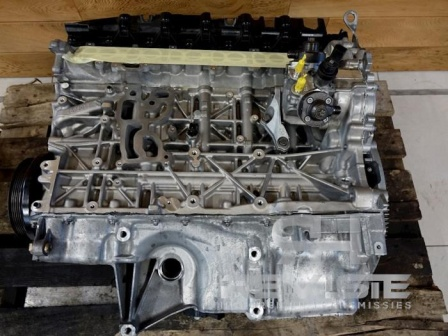Imagine this engine block being part of a futuristic eco-friendly vehicle. Describe its new role and modifications. In a futuristic world committed to sustainability, this engine block has been profoundly transformed to suit an eco-friendly vehicle. Instead of relying on traditional fossil fuels, it's retrofitted to work seamlessly with a hybrid system combining hydrogen fuel cells and electric power. 

The silver metal surface of the engine block is now gleaming with advanced coatings that improve heat dissipation, reducing energy waste. The once conventional piston and cylinder configuration have been re-engineered for optimum efficiency, minimizing internal friction and maximizing power output. Metal pipes and tubes formerly part of the liquid cooling system now circulate a cutting-edge nanofluid coolant, ensuring superior temperature regulation with minimal environmental impact. 

This engine block now features intelligent sensors and AI-driven control systems that adapt to driving conditions in real-time, maximizing performance and efficiency. These sensors provide continuous feedback to the central computer system of the vehicle, allowing it to make smart adjustments that balance power and fuel consumption. 

Underneath its streamlined black cover, the block conceals advanced air filtration systems that purify intake air, ensuring that emissions are significantly reduced. The yellow reservoir cap is now a part of an integrated self-maintenance system that monitors fluid levels and automatically dispenses biodegradable lubricants as needed. 

Part of a vehicle that emits water vapor as its only exhaust, this engine block illustrates a significant leap towards a carbon-neutral future, proving that innovation and sustainability can go hand in hand. 